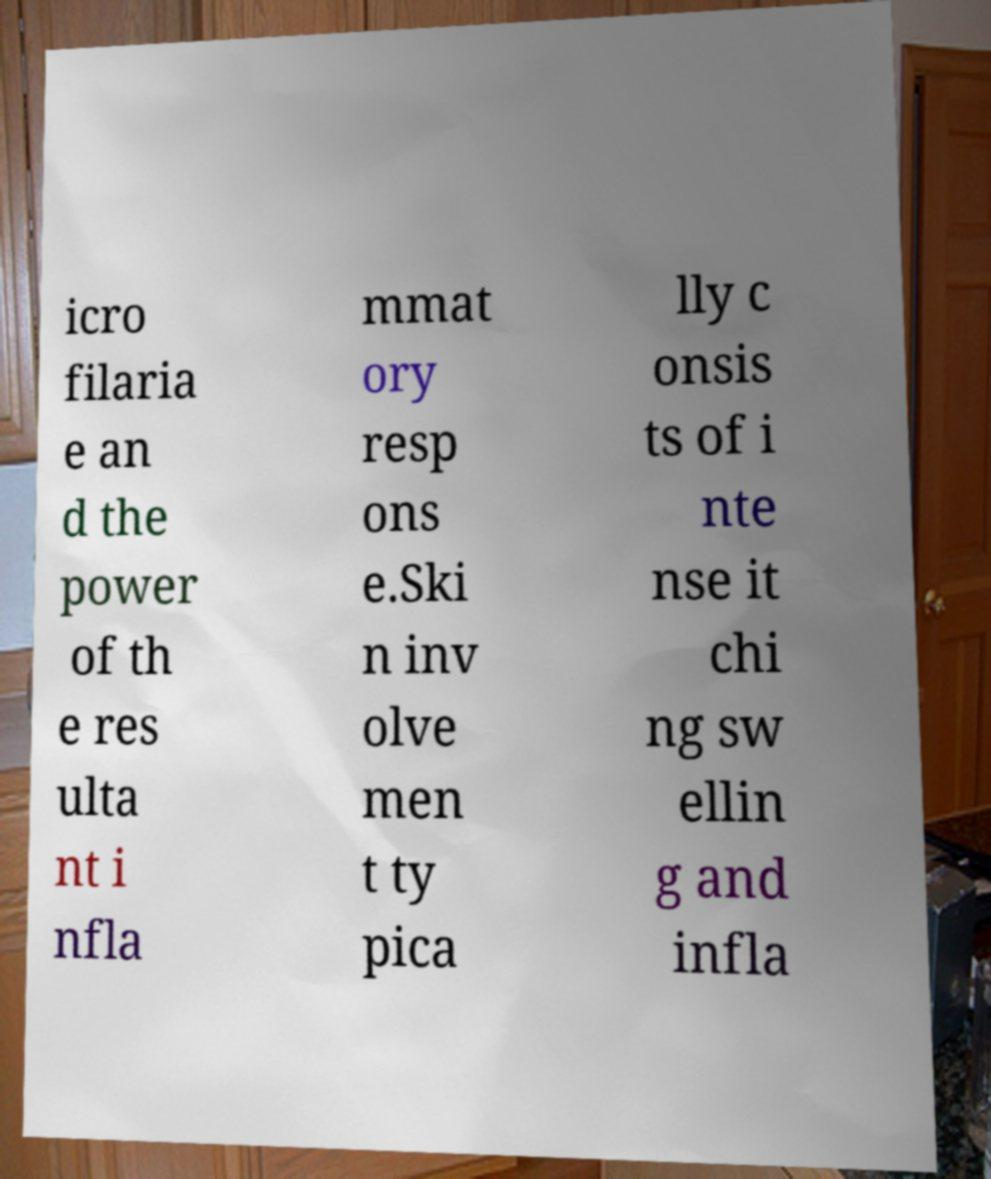Please read and relay the text visible in this image. What does it say? icro filaria e an d the power of th e res ulta nt i nfla mmat ory resp ons e.Ski n inv olve men t ty pica lly c onsis ts of i nte nse it chi ng sw ellin g and infla 